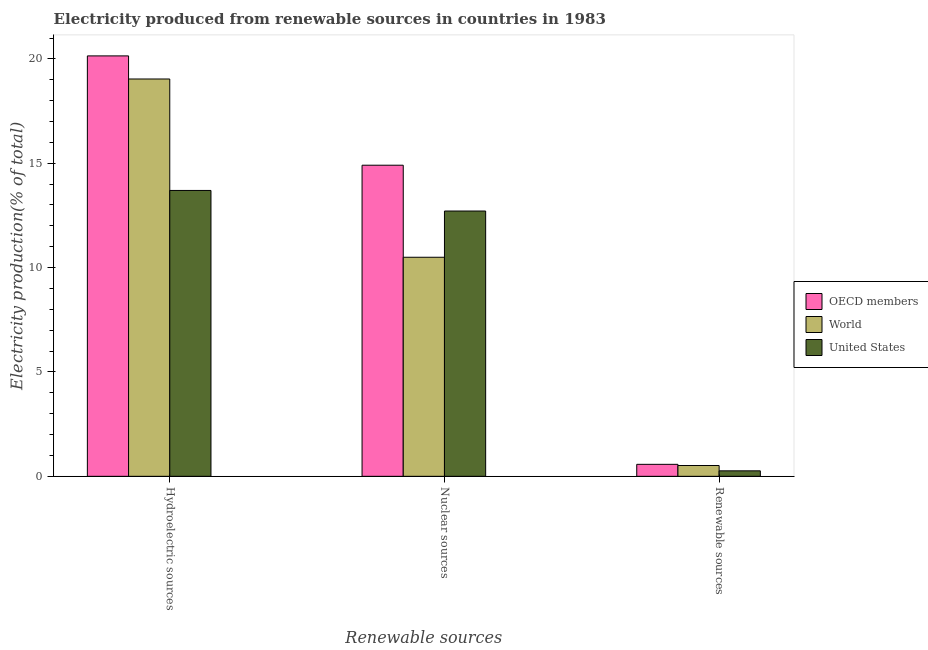How many different coloured bars are there?
Your answer should be very brief. 3. Are the number of bars per tick equal to the number of legend labels?
Offer a terse response. Yes. Are the number of bars on each tick of the X-axis equal?
Your response must be concise. Yes. How many bars are there on the 1st tick from the right?
Make the answer very short. 3. What is the label of the 3rd group of bars from the left?
Ensure brevity in your answer.  Renewable sources. What is the percentage of electricity produced by nuclear sources in OECD members?
Make the answer very short. 14.91. Across all countries, what is the maximum percentage of electricity produced by nuclear sources?
Your response must be concise. 14.91. Across all countries, what is the minimum percentage of electricity produced by renewable sources?
Ensure brevity in your answer.  0.26. In which country was the percentage of electricity produced by nuclear sources maximum?
Your response must be concise. OECD members. What is the total percentage of electricity produced by hydroelectric sources in the graph?
Make the answer very short. 52.88. What is the difference between the percentage of electricity produced by renewable sources in World and that in United States?
Keep it short and to the point. 0.26. What is the difference between the percentage of electricity produced by hydroelectric sources in World and the percentage of electricity produced by renewable sources in OECD members?
Make the answer very short. 18.46. What is the average percentage of electricity produced by hydroelectric sources per country?
Your answer should be very brief. 17.63. What is the difference between the percentage of electricity produced by renewable sources and percentage of electricity produced by hydroelectric sources in World?
Provide a short and direct response. -18.52. What is the ratio of the percentage of electricity produced by nuclear sources in World to that in United States?
Your answer should be compact. 0.83. What is the difference between the highest and the second highest percentage of electricity produced by hydroelectric sources?
Your answer should be compact. 1.11. What is the difference between the highest and the lowest percentage of electricity produced by nuclear sources?
Provide a succinct answer. 4.41. In how many countries, is the percentage of electricity produced by renewable sources greater than the average percentage of electricity produced by renewable sources taken over all countries?
Offer a very short reply. 2. What does the 3rd bar from the left in Nuclear sources represents?
Your response must be concise. United States. How many bars are there?
Your answer should be compact. 9. How many countries are there in the graph?
Provide a succinct answer. 3. What is the difference between two consecutive major ticks on the Y-axis?
Offer a terse response. 5. Are the values on the major ticks of Y-axis written in scientific E-notation?
Your answer should be compact. No. Does the graph contain grids?
Make the answer very short. No. How many legend labels are there?
Give a very brief answer. 3. What is the title of the graph?
Your answer should be compact. Electricity produced from renewable sources in countries in 1983. What is the label or title of the X-axis?
Your response must be concise. Renewable sources. What is the label or title of the Y-axis?
Provide a short and direct response. Electricity production(% of total). What is the Electricity production(% of total) of OECD members in Hydroelectric sources?
Give a very brief answer. 20.14. What is the Electricity production(% of total) of World in Hydroelectric sources?
Provide a succinct answer. 19.04. What is the Electricity production(% of total) of United States in Hydroelectric sources?
Make the answer very short. 13.7. What is the Electricity production(% of total) of OECD members in Nuclear sources?
Offer a very short reply. 14.91. What is the Electricity production(% of total) in World in Nuclear sources?
Your answer should be compact. 10.5. What is the Electricity production(% of total) in United States in Nuclear sources?
Provide a short and direct response. 12.71. What is the Electricity production(% of total) of OECD members in Renewable sources?
Offer a terse response. 0.57. What is the Electricity production(% of total) in World in Renewable sources?
Provide a succinct answer. 0.52. What is the Electricity production(% of total) in United States in Renewable sources?
Offer a terse response. 0.26. Across all Renewable sources, what is the maximum Electricity production(% of total) of OECD members?
Give a very brief answer. 20.14. Across all Renewable sources, what is the maximum Electricity production(% of total) of World?
Make the answer very short. 19.04. Across all Renewable sources, what is the maximum Electricity production(% of total) of United States?
Your answer should be compact. 13.7. Across all Renewable sources, what is the minimum Electricity production(% of total) in OECD members?
Offer a terse response. 0.57. Across all Renewable sources, what is the minimum Electricity production(% of total) of World?
Your answer should be compact. 0.52. Across all Renewable sources, what is the minimum Electricity production(% of total) in United States?
Your answer should be compact. 0.26. What is the total Electricity production(% of total) of OECD members in the graph?
Offer a terse response. 35.62. What is the total Electricity production(% of total) of World in the graph?
Make the answer very short. 30.05. What is the total Electricity production(% of total) of United States in the graph?
Your response must be concise. 26.67. What is the difference between the Electricity production(% of total) of OECD members in Hydroelectric sources and that in Nuclear sources?
Provide a short and direct response. 5.24. What is the difference between the Electricity production(% of total) in World in Hydroelectric sources and that in Nuclear sources?
Offer a terse response. 8.54. What is the difference between the Electricity production(% of total) of United States in Hydroelectric sources and that in Nuclear sources?
Make the answer very short. 0.99. What is the difference between the Electricity production(% of total) of OECD members in Hydroelectric sources and that in Renewable sources?
Your response must be concise. 19.57. What is the difference between the Electricity production(% of total) in World in Hydroelectric sources and that in Renewable sources?
Ensure brevity in your answer.  18.52. What is the difference between the Electricity production(% of total) of United States in Hydroelectric sources and that in Renewable sources?
Provide a short and direct response. 13.43. What is the difference between the Electricity production(% of total) in OECD members in Nuclear sources and that in Renewable sources?
Make the answer very short. 14.33. What is the difference between the Electricity production(% of total) of World in Nuclear sources and that in Renewable sources?
Provide a succinct answer. 9.98. What is the difference between the Electricity production(% of total) of United States in Nuclear sources and that in Renewable sources?
Your answer should be very brief. 12.45. What is the difference between the Electricity production(% of total) of OECD members in Hydroelectric sources and the Electricity production(% of total) of World in Nuclear sources?
Offer a terse response. 9.65. What is the difference between the Electricity production(% of total) of OECD members in Hydroelectric sources and the Electricity production(% of total) of United States in Nuclear sources?
Your response must be concise. 7.43. What is the difference between the Electricity production(% of total) of World in Hydroelectric sources and the Electricity production(% of total) of United States in Nuclear sources?
Your answer should be very brief. 6.33. What is the difference between the Electricity production(% of total) of OECD members in Hydroelectric sources and the Electricity production(% of total) of World in Renewable sources?
Your answer should be very brief. 19.63. What is the difference between the Electricity production(% of total) of OECD members in Hydroelectric sources and the Electricity production(% of total) of United States in Renewable sources?
Your response must be concise. 19.88. What is the difference between the Electricity production(% of total) in World in Hydroelectric sources and the Electricity production(% of total) in United States in Renewable sources?
Offer a terse response. 18.77. What is the difference between the Electricity production(% of total) of OECD members in Nuclear sources and the Electricity production(% of total) of World in Renewable sources?
Provide a succinct answer. 14.39. What is the difference between the Electricity production(% of total) in OECD members in Nuclear sources and the Electricity production(% of total) in United States in Renewable sources?
Provide a short and direct response. 14.64. What is the difference between the Electricity production(% of total) of World in Nuclear sources and the Electricity production(% of total) of United States in Renewable sources?
Provide a short and direct response. 10.23. What is the average Electricity production(% of total) in OECD members per Renewable sources?
Your answer should be very brief. 11.87. What is the average Electricity production(% of total) of World per Renewable sources?
Your answer should be compact. 10.02. What is the average Electricity production(% of total) of United States per Renewable sources?
Make the answer very short. 8.89. What is the difference between the Electricity production(% of total) in OECD members and Electricity production(% of total) in World in Hydroelectric sources?
Provide a short and direct response. 1.11. What is the difference between the Electricity production(% of total) of OECD members and Electricity production(% of total) of United States in Hydroelectric sources?
Provide a succinct answer. 6.45. What is the difference between the Electricity production(% of total) of World and Electricity production(% of total) of United States in Hydroelectric sources?
Your answer should be compact. 5.34. What is the difference between the Electricity production(% of total) in OECD members and Electricity production(% of total) in World in Nuclear sources?
Your answer should be very brief. 4.41. What is the difference between the Electricity production(% of total) of OECD members and Electricity production(% of total) of United States in Nuclear sources?
Offer a terse response. 2.2. What is the difference between the Electricity production(% of total) in World and Electricity production(% of total) in United States in Nuclear sources?
Ensure brevity in your answer.  -2.22. What is the difference between the Electricity production(% of total) in OECD members and Electricity production(% of total) in World in Renewable sources?
Give a very brief answer. 0.06. What is the difference between the Electricity production(% of total) of OECD members and Electricity production(% of total) of United States in Renewable sources?
Your answer should be compact. 0.31. What is the difference between the Electricity production(% of total) in World and Electricity production(% of total) in United States in Renewable sources?
Provide a succinct answer. 0.26. What is the ratio of the Electricity production(% of total) of OECD members in Hydroelectric sources to that in Nuclear sources?
Offer a very short reply. 1.35. What is the ratio of the Electricity production(% of total) in World in Hydroelectric sources to that in Nuclear sources?
Your answer should be very brief. 1.81. What is the ratio of the Electricity production(% of total) of United States in Hydroelectric sources to that in Nuclear sources?
Keep it short and to the point. 1.08. What is the ratio of the Electricity production(% of total) in OECD members in Hydroelectric sources to that in Renewable sources?
Offer a very short reply. 35.11. What is the ratio of the Electricity production(% of total) of World in Hydroelectric sources to that in Renewable sources?
Keep it short and to the point. 36.77. What is the ratio of the Electricity production(% of total) in United States in Hydroelectric sources to that in Renewable sources?
Your answer should be compact. 52.2. What is the ratio of the Electricity production(% of total) of OECD members in Nuclear sources to that in Renewable sources?
Give a very brief answer. 25.98. What is the ratio of the Electricity production(% of total) in World in Nuclear sources to that in Renewable sources?
Ensure brevity in your answer.  20.27. What is the ratio of the Electricity production(% of total) in United States in Nuclear sources to that in Renewable sources?
Ensure brevity in your answer.  48.44. What is the difference between the highest and the second highest Electricity production(% of total) in OECD members?
Make the answer very short. 5.24. What is the difference between the highest and the second highest Electricity production(% of total) in World?
Give a very brief answer. 8.54. What is the difference between the highest and the second highest Electricity production(% of total) in United States?
Make the answer very short. 0.99. What is the difference between the highest and the lowest Electricity production(% of total) of OECD members?
Make the answer very short. 19.57. What is the difference between the highest and the lowest Electricity production(% of total) of World?
Keep it short and to the point. 18.52. What is the difference between the highest and the lowest Electricity production(% of total) in United States?
Make the answer very short. 13.43. 